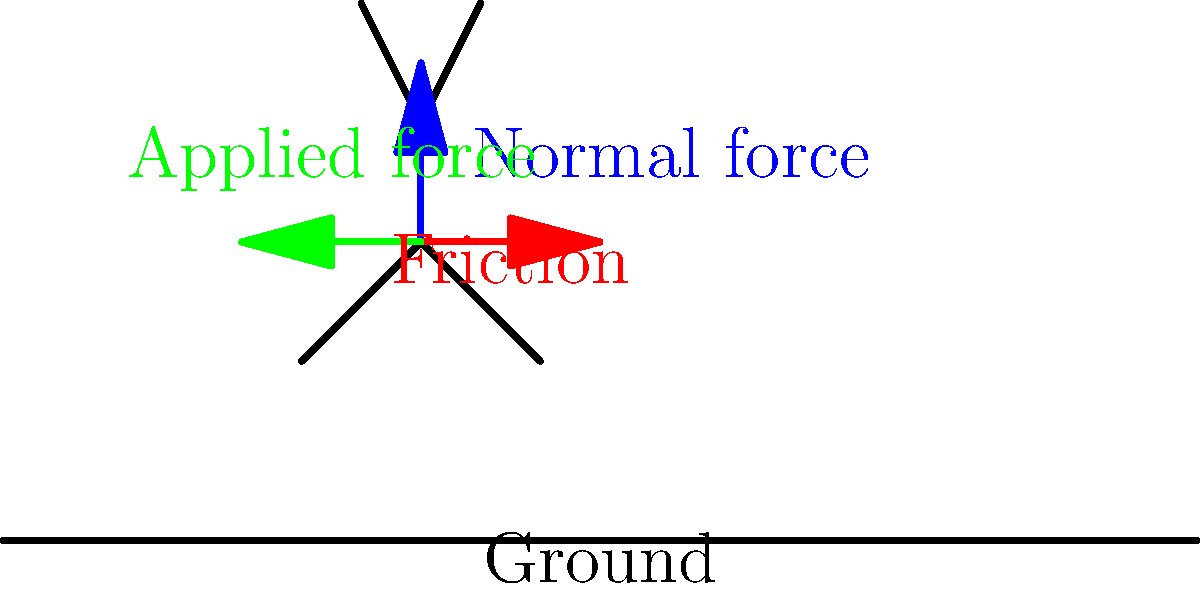During a sliding tackle, a soccer player exerts a horizontal force of 500 N on the ground. The coefficient of kinetic friction between the player and the grass is 0.2, and the player's mass is 70 kg. Calculate the magnitude of the friction force acting on the player during the slide. To solve this problem, we'll follow these steps:

1) First, we need to identify the forces acting on the player:
   - Normal force (N) acting upwards
   - Weight (W) acting downwards
   - Applied force (F) acting horizontally
   - Friction force (f) acting horizontally in the opposite direction of motion

2) We know that in equilibrium, the normal force equals the weight of the player:
   $N = mg = 70 \text{ kg} \times 9.8 \text{ m/s}^2 = 686 \text{ N}$

3) The formula for kinetic friction is:
   $f = \mu_k N$
   where $\mu_k$ is the coefficient of kinetic friction

4) We're given that $\mu_k = 0.2$

5) Now we can calculate the friction force:
   $f = 0.2 \times 686 \text{ N} = 137.2 \text{ N}$

6) Therefore, the magnitude of the friction force acting on the player during the slide is 137.2 N.

Note: The applied force of 500 N doesn't directly affect the friction force in this case. The friction force depends only on the normal force and the coefficient of friction.
Answer: 137.2 N 